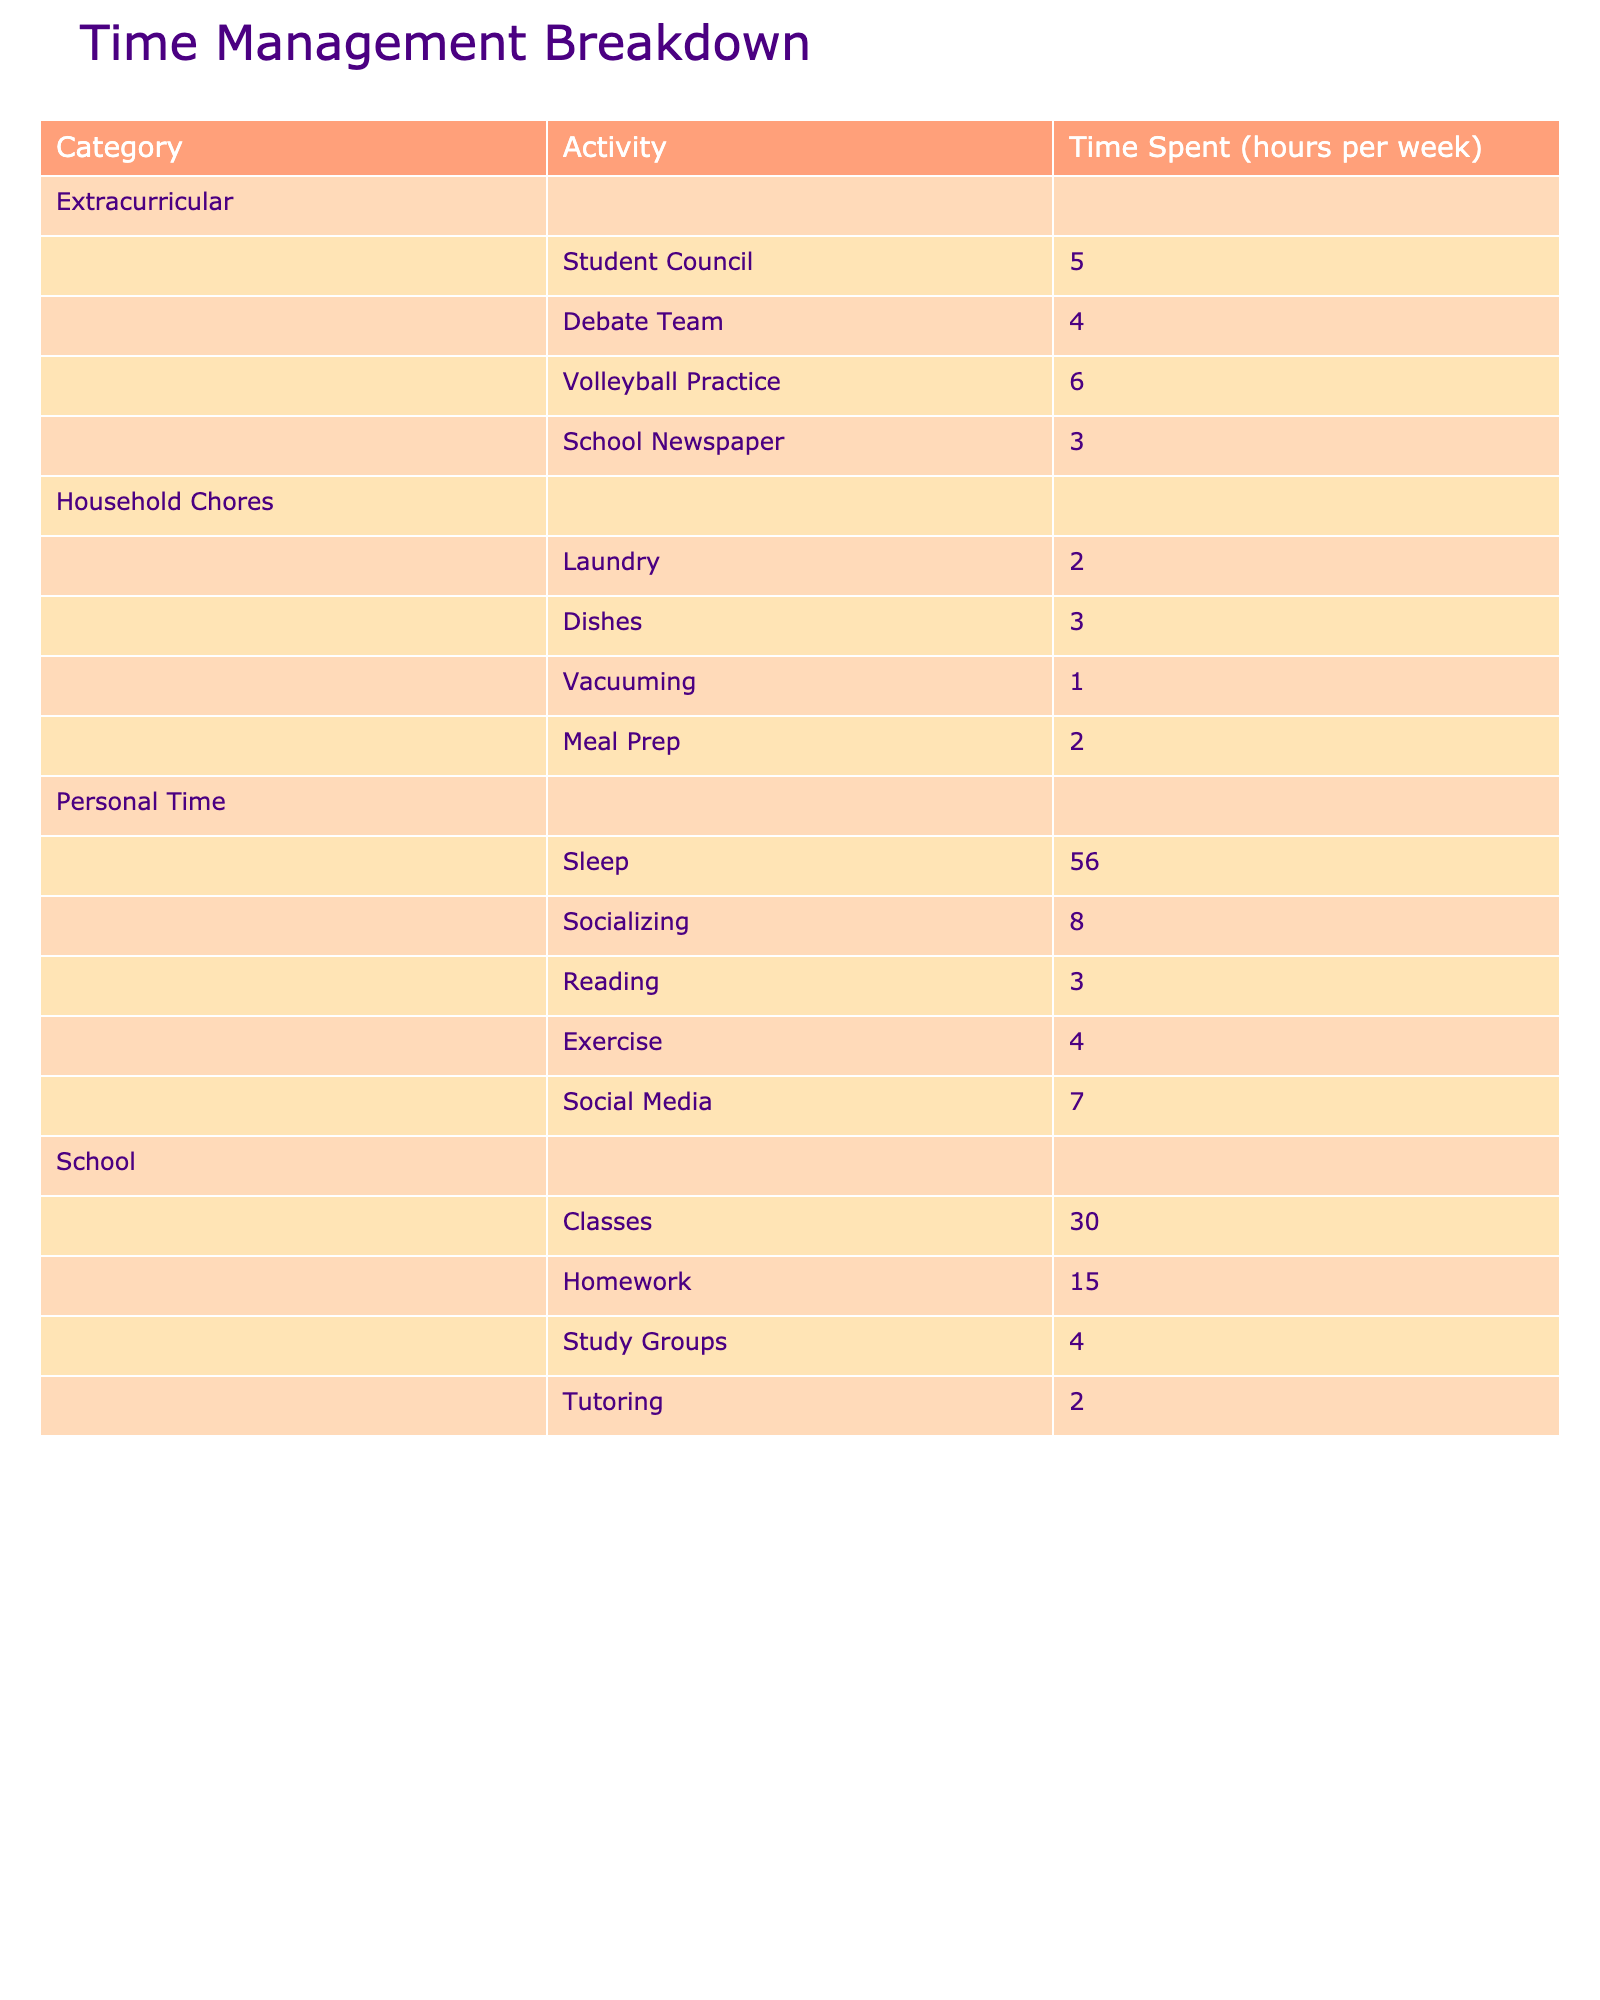What's the total time spent on homework? Looking at the table under the 'School' category, the time spent on homework is listed as 15 hours per week.
Answer: 15 hours Which extracurricular activity takes the most time? In the 'Extracurricular' category, Volleyball Practice has the highest time spent at 6 hours per week, more than any other listed activity.
Answer: Volleyball Practice What is the total time spent on household chores? The time spent on household chores includes Laundry (2 hours), Dishes (3 hours), Vacuuming (1 hour), and Meal Prep (2 hours). Adding these values gives 2 + 3 + 1 + 2 = 8 hours total.
Answer: 8 hours Is the time spent sleeping greater than the time spent on all school activities combined? Total school hours (Classes + Homework + Study Groups + Tutoring) are 30 + 15 + 4 + 2 = 51 hours. Sleeping time is 56 hours, which is greater than 51 hours.
Answer: Yes What percentage of the total weekly time is spent on personal time activities? The total time in a week is 168 hours. Personal time totals to 56 (Sleep) + 8 (Socializing) + 3 (Reading) + 4 (Exercise) + 7 (Social Media) = 78 hours. Calculating the percentage gives (78/168) * 100 ≈ 46.43%.
Answer: Approximately 46.43% How many more hours are spent in total on school activities compared to household chores? Total hours for school (51 hours) minus total hours for household chores (8 hours) gives 51 - 8 = 43 hours more spent on school activities.
Answer: 43 hours What is the average time spent per week across all activities in the table? Summing all time spent gives 30 + 15 + 4 + 2 + 5 + 4 + 6 + 3 + 2 + 3 + 1 + 2 + 56 + 8 + 3 + 4 + 7 = 152 hours. There are 17 activities listed, so the average is 152/17 ≈ 8.94 hours.
Answer: Approximately 8.94 hours Are there any activities listed that require less than 2 hours a week? Looking at the household chores, Vacuuming is listed at 1 hour, which is less than 2 hours.
Answer: Yes, Vacuuming What is the total time difference between personal time and extracurricular activities? Total personal time is 78 hours and total extracurricular time is 18 hours (5 + 4 + 6 + 3). The difference is 78 - 18 = 60 hours.
Answer: 60 hours Which category has the least total time spent and what is that time? The ‘Household Chores’ category has the least time spent at 8 hours compared to other categories.
Answer: 8 hours 